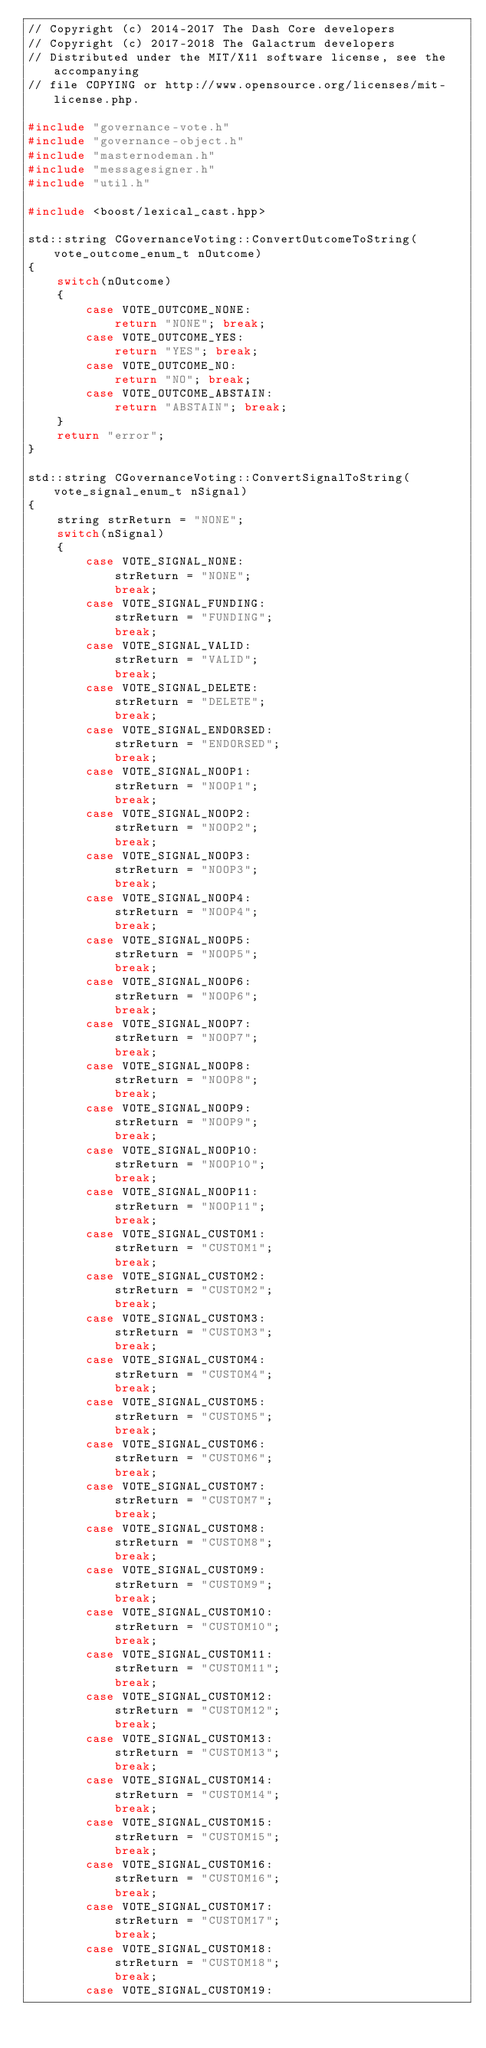<code> <loc_0><loc_0><loc_500><loc_500><_C++_>// Copyright (c) 2014-2017 The Dash Core developers
// Copyright (c) 2017-2018 The Galactrum developers
// Distributed under the MIT/X11 software license, see the accompanying
// file COPYING or http://www.opensource.org/licenses/mit-license.php.

#include "governance-vote.h"
#include "governance-object.h"
#include "masternodeman.h"
#include "messagesigner.h"
#include "util.h"

#include <boost/lexical_cast.hpp>

std::string CGovernanceVoting::ConvertOutcomeToString(vote_outcome_enum_t nOutcome)
{
    switch(nOutcome)
    {
        case VOTE_OUTCOME_NONE:
            return "NONE"; break;
        case VOTE_OUTCOME_YES:
            return "YES"; break;
        case VOTE_OUTCOME_NO:
            return "NO"; break;
        case VOTE_OUTCOME_ABSTAIN:
            return "ABSTAIN"; break;
    }
    return "error";
}

std::string CGovernanceVoting::ConvertSignalToString(vote_signal_enum_t nSignal)
{
    string strReturn = "NONE";
    switch(nSignal)
    {
        case VOTE_SIGNAL_NONE:
            strReturn = "NONE";
            break;
        case VOTE_SIGNAL_FUNDING:
            strReturn = "FUNDING";
            break;
        case VOTE_SIGNAL_VALID:
            strReturn = "VALID";
            break;
        case VOTE_SIGNAL_DELETE:
            strReturn = "DELETE";
            break;
        case VOTE_SIGNAL_ENDORSED:
            strReturn = "ENDORSED";
            break;
        case VOTE_SIGNAL_NOOP1:
            strReturn = "NOOP1";
            break;
        case VOTE_SIGNAL_NOOP2:
            strReturn = "NOOP2";
            break;
        case VOTE_SIGNAL_NOOP3:
            strReturn = "NOOP3";
            break;
        case VOTE_SIGNAL_NOOP4:
            strReturn = "NOOP4";
            break;
        case VOTE_SIGNAL_NOOP5:
            strReturn = "NOOP5";
            break;
        case VOTE_SIGNAL_NOOP6:
            strReturn = "NOOP6";
            break;
        case VOTE_SIGNAL_NOOP7:
            strReturn = "NOOP7";
            break;
        case VOTE_SIGNAL_NOOP8:
            strReturn = "NOOP8";
            break;
        case VOTE_SIGNAL_NOOP9:
            strReturn = "NOOP9";
            break;
        case VOTE_SIGNAL_NOOP10:
            strReturn = "NOOP10";
            break;
        case VOTE_SIGNAL_NOOP11:
            strReturn = "NOOP11";
            break;
        case VOTE_SIGNAL_CUSTOM1:
            strReturn = "CUSTOM1";
            break;
        case VOTE_SIGNAL_CUSTOM2:
            strReturn = "CUSTOM2";
            break;
        case VOTE_SIGNAL_CUSTOM3:
            strReturn = "CUSTOM3";
            break;
        case VOTE_SIGNAL_CUSTOM4:
            strReturn = "CUSTOM4";
            break;
        case VOTE_SIGNAL_CUSTOM5:
            strReturn = "CUSTOM5";
            break;
        case VOTE_SIGNAL_CUSTOM6:
            strReturn = "CUSTOM6";
            break;
        case VOTE_SIGNAL_CUSTOM7:
            strReturn = "CUSTOM7";
            break;
        case VOTE_SIGNAL_CUSTOM8:
            strReturn = "CUSTOM8";
            break;
        case VOTE_SIGNAL_CUSTOM9:
            strReturn = "CUSTOM9";
            break;
        case VOTE_SIGNAL_CUSTOM10:
            strReturn = "CUSTOM10";
            break;
        case VOTE_SIGNAL_CUSTOM11:
            strReturn = "CUSTOM11";
            break;
        case VOTE_SIGNAL_CUSTOM12:
            strReturn = "CUSTOM12";
            break;
        case VOTE_SIGNAL_CUSTOM13:
            strReturn = "CUSTOM13";
            break;
        case VOTE_SIGNAL_CUSTOM14:
            strReturn = "CUSTOM14";
            break;
        case VOTE_SIGNAL_CUSTOM15:
            strReturn = "CUSTOM15";
            break;
        case VOTE_SIGNAL_CUSTOM16:
            strReturn = "CUSTOM16";
            break;
        case VOTE_SIGNAL_CUSTOM17:
            strReturn = "CUSTOM17";
            break;
        case VOTE_SIGNAL_CUSTOM18:
            strReturn = "CUSTOM18";
            break;
        case VOTE_SIGNAL_CUSTOM19:</code> 